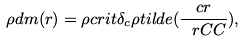Convert formula to latex. <formula><loc_0><loc_0><loc_500><loc_500>\rho d m ( r ) = \rho c r i t \delta _ { c } \rho t i l d e ( \frac { c r } { \ r C C } ) , \\</formula> 